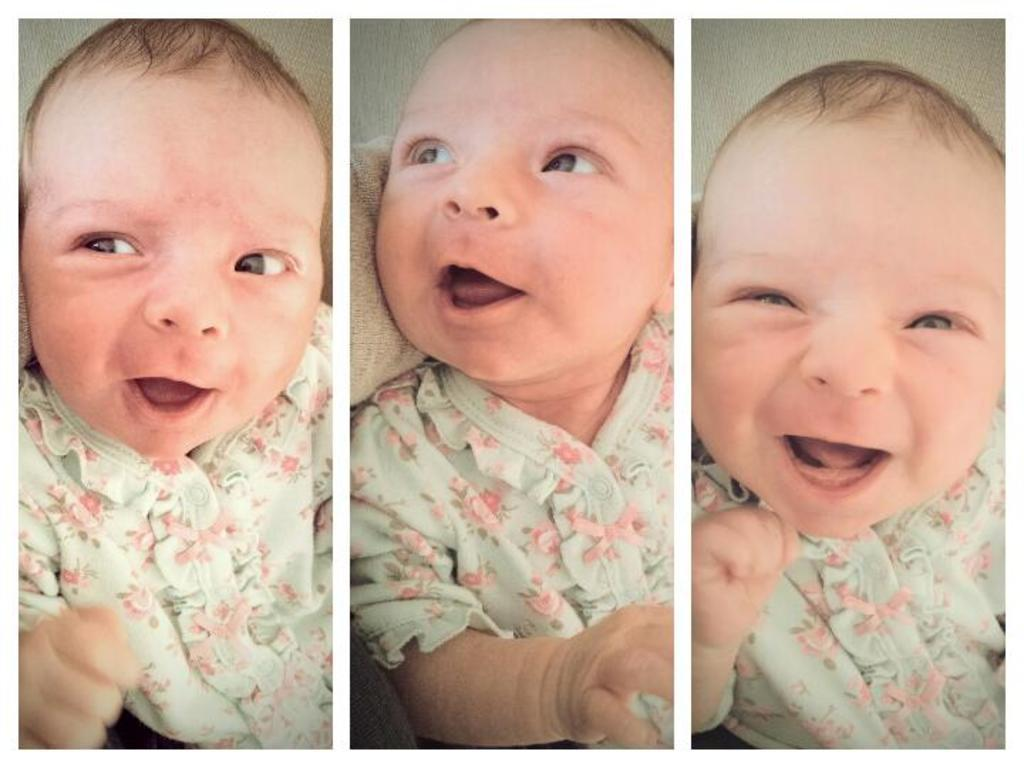What is the main subject of the three pictures in the image? The main subject of the three pictures is the same kid. How does the kid's expression differ in each picture? The kid has different expressions in each picture. Can you describe any additional objects or elements in the middle picture? Yes, there is a cloth visible in the middle picture. What type of lead can be seen in the image? There is no lead present in the image. What does the kid need in the image? The image does not provide information about the kid's needs. 